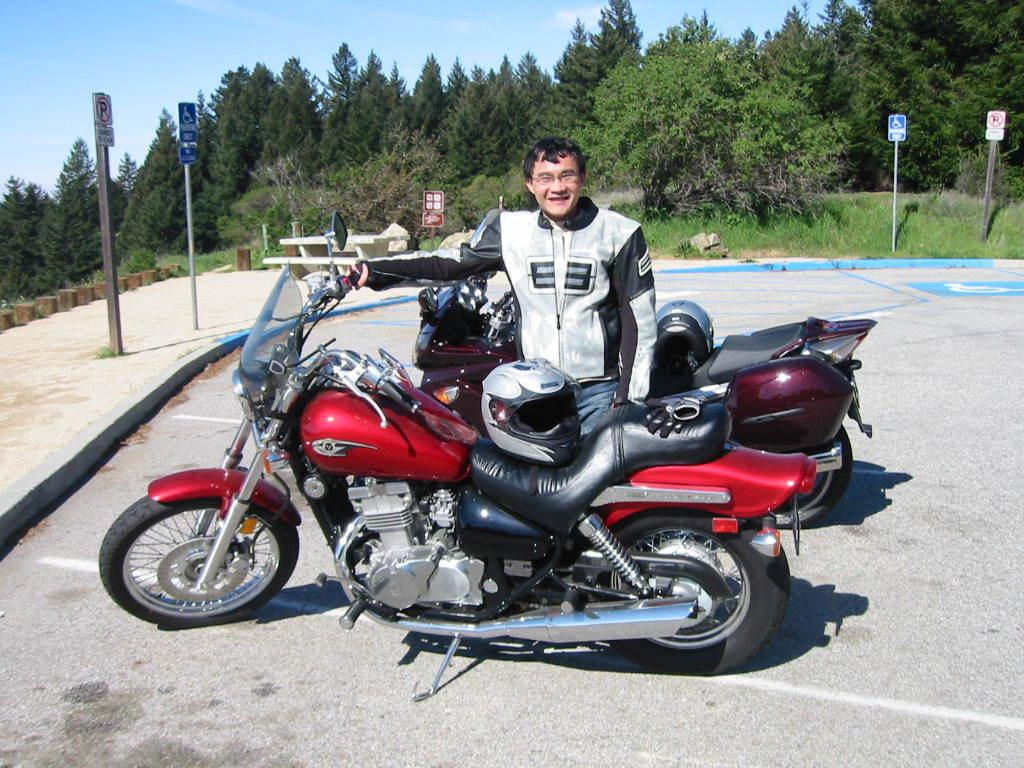What is the man in the image doing? The man is standing and smiling in the image. What is the man holding in the image? The man is holding a bike in the image. Are there any safety precautions visible in the image? Yes, there are helmets on the bikes in the image. What can be seen in the background of the image? In the background, there are boards on poles, a bench, a table, grass, trees, and the sky. What is the reason for the hen's presence in the image? There is no hen present in the image. 